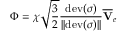Convert formula to latex. <formula><loc_0><loc_0><loc_500><loc_500>\boldsymbol \Phi = \chi \sqrt { \frac { 3 } { 2 } } \frac { d e v ( \boldsymbol \sigma ) } { | | d e v ( \boldsymbol \sigma ) | | } \overline { V } _ { e }</formula> 